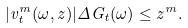<formula> <loc_0><loc_0><loc_500><loc_500>| v ^ { m } _ { t } ( \omega , z ) | \Delta G _ { t } ( \omega ) \leq z ^ { m } .</formula> 